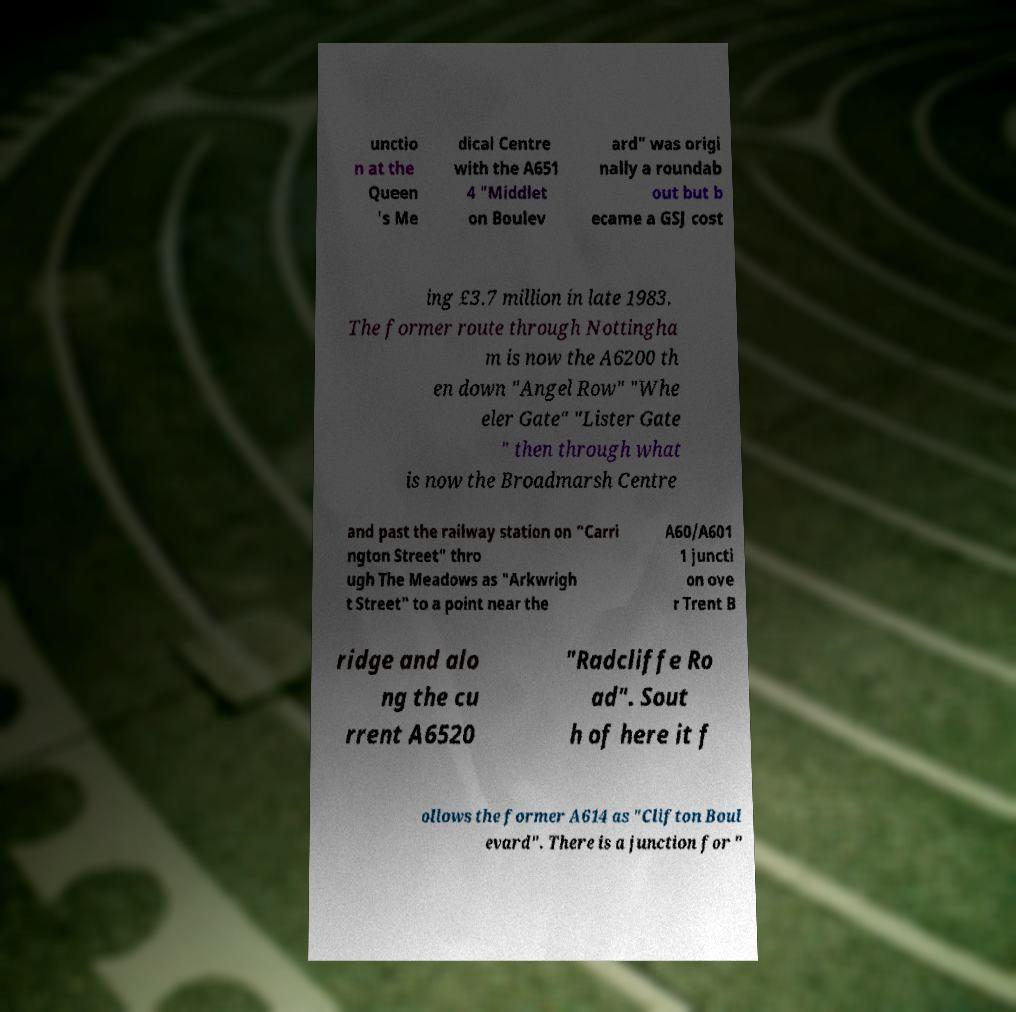Please read and relay the text visible in this image. What does it say? unctio n at the Queen 's Me dical Centre with the A651 4 "Middlet on Boulev ard" was origi nally a roundab out but b ecame a GSJ cost ing £3.7 million in late 1983. The former route through Nottingha m is now the A6200 th en down "Angel Row" "Whe eler Gate" "Lister Gate " then through what is now the Broadmarsh Centre and past the railway station on "Carri ngton Street" thro ugh The Meadows as "Arkwrigh t Street" to a point near the A60/A601 1 juncti on ove r Trent B ridge and alo ng the cu rrent A6520 "Radcliffe Ro ad". Sout h of here it f ollows the former A614 as "Clifton Boul evard". There is a junction for " 